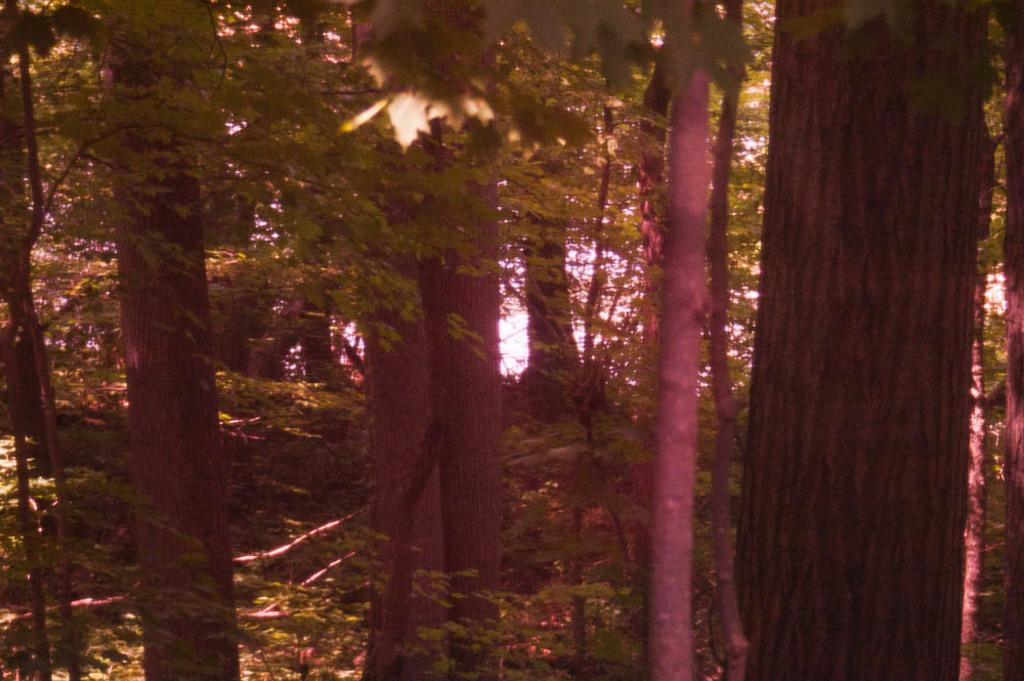What type of vegetation can be seen in the image? There are trees, tree branches, and plants visible in the image. What is the ground covered with in the image? Grass is present in the image. What type of pancake is being used as a lamp in the image? There is no pancake or lamp present in the image. 